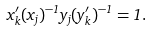<formula> <loc_0><loc_0><loc_500><loc_500>x ^ { \prime } _ { k } ( x _ { j } ) ^ { - 1 } y _ { j } ( y ^ { \prime } _ { k } ) ^ { - 1 } = 1 .</formula> 